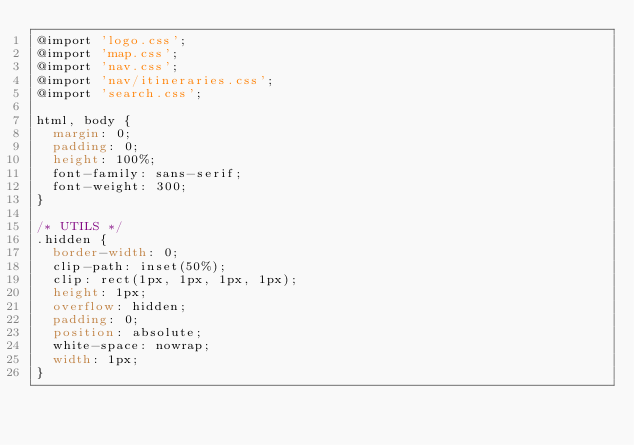<code> <loc_0><loc_0><loc_500><loc_500><_CSS_>@import 'logo.css';
@import 'map.css';
@import 'nav.css';
@import 'nav/itineraries.css';
@import 'search.css';

html, body {
  margin: 0;
  padding: 0;
  height: 100%;
  font-family: sans-serif;
  font-weight: 300;
}

/* UTILS */
.hidden {
  border-width: 0;
  clip-path: inset(50%);
  clip: rect(1px, 1px, 1px, 1px);
  height: 1px;
  overflow: hidden;
  padding: 0;
  position: absolute;
  white-space: nowrap;
  width: 1px;
}</code> 